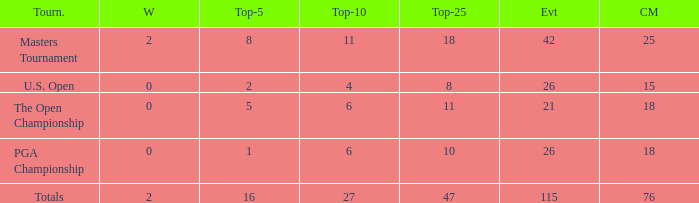What is the average Top-10 with a greater than 11 Top-25 and a less than 2 wins? None. 